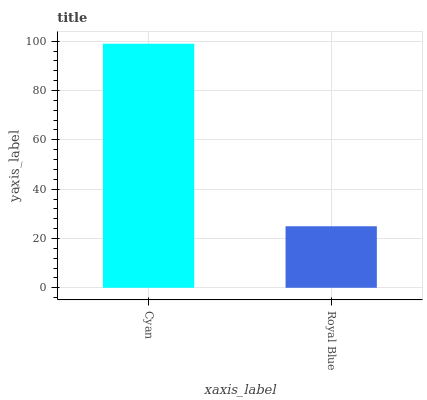Is Royal Blue the minimum?
Answer yes or no. Yes. Is Cyan the maximum?
Answer yes or no. Yes. Is Royal Blue the maximum?
Answer yes or no. No. Is Cyan greater than Royal Blue?
Answer yes or no. Yes. Is Royal Blue less than Cyan?
Answer yes or no. Yes. Is Royal Blue greater than Cyan?
Answer yes or no. No. Is Cyan less than Royal Blue?
Answer yes or no. No. Is Cyan the high median?
Answer yes or no. Yes. Is Royal Blue the low median?
Answer yes or no. Yes. Is Royal Blue the high median?
Answer yes or no. No. Is Cyan the low median?
Answer yes or no. No. 